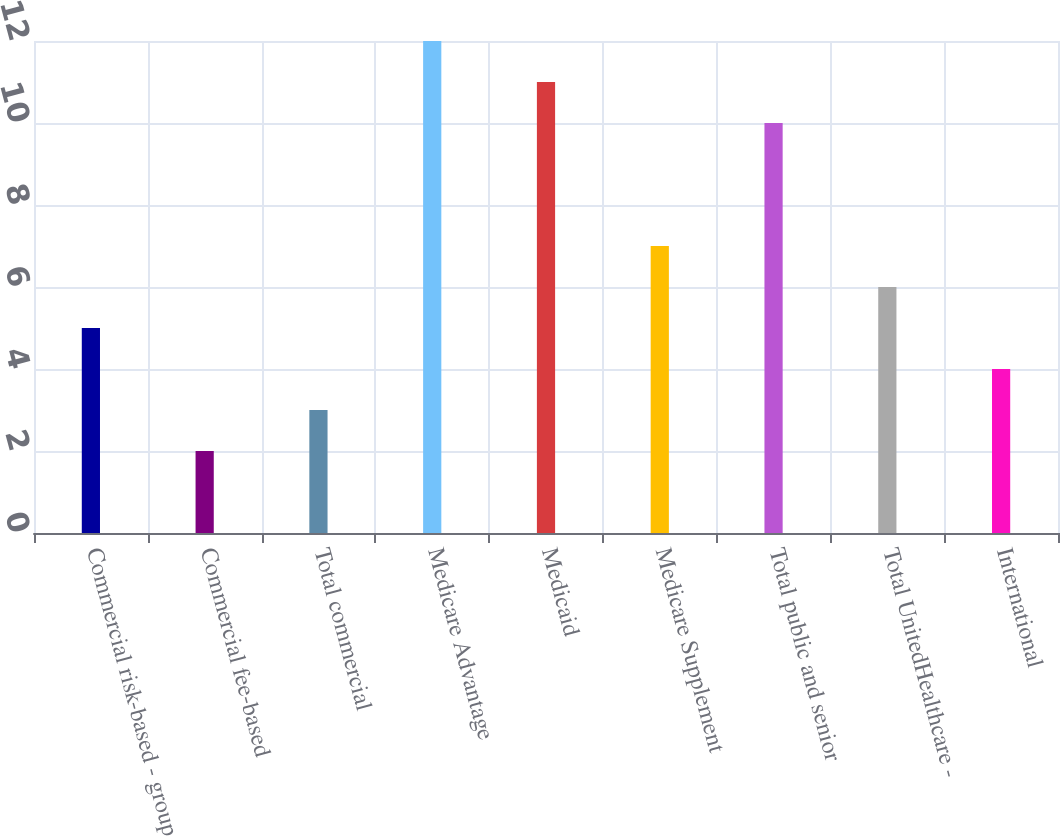Convert chart. <chart><loc_0><loc_0><loc_500><loc_500><bar_chart><fcel>Commercial risk-based - group<fcel>Commercial fee-based<fcel>Total commercial<fcel>Medicare Advantage<fcel>Medicaid<fcel>Medicare Supplement<fcel>Total public and senior<fcel>Total UnitedHealthcare -<fcel>International<nl><fcel>5<fcel>2<fcel>3<fcel>12<fcel>11<fcel>7<fcel>10<fcel>6<fcel>4<nl></chart> 